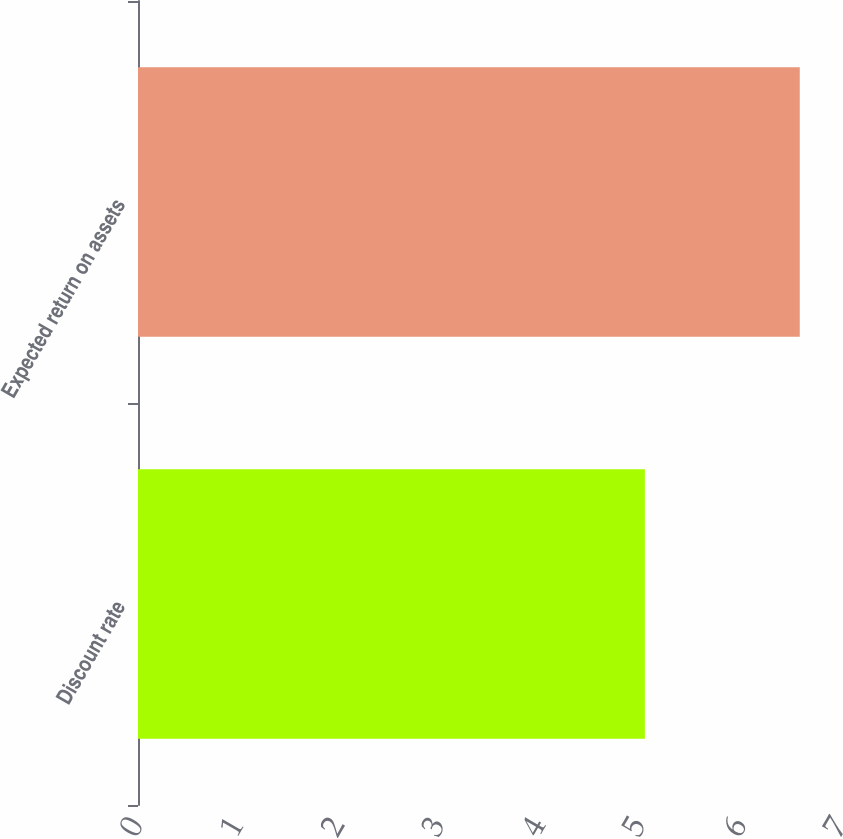Convert chart to OTSL. <chart><loc_0><loc_0><loc_500><loc_500><bar_chart><fcel>Discount rate<fcel>Expected return on assets<nl><fcel>5.04<fcel>6.58<nl></chart> 